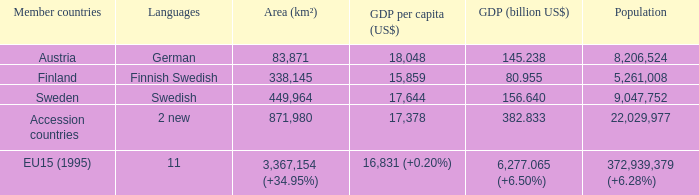Name the population for 11 languages 372,939,379 (+6.28%). 